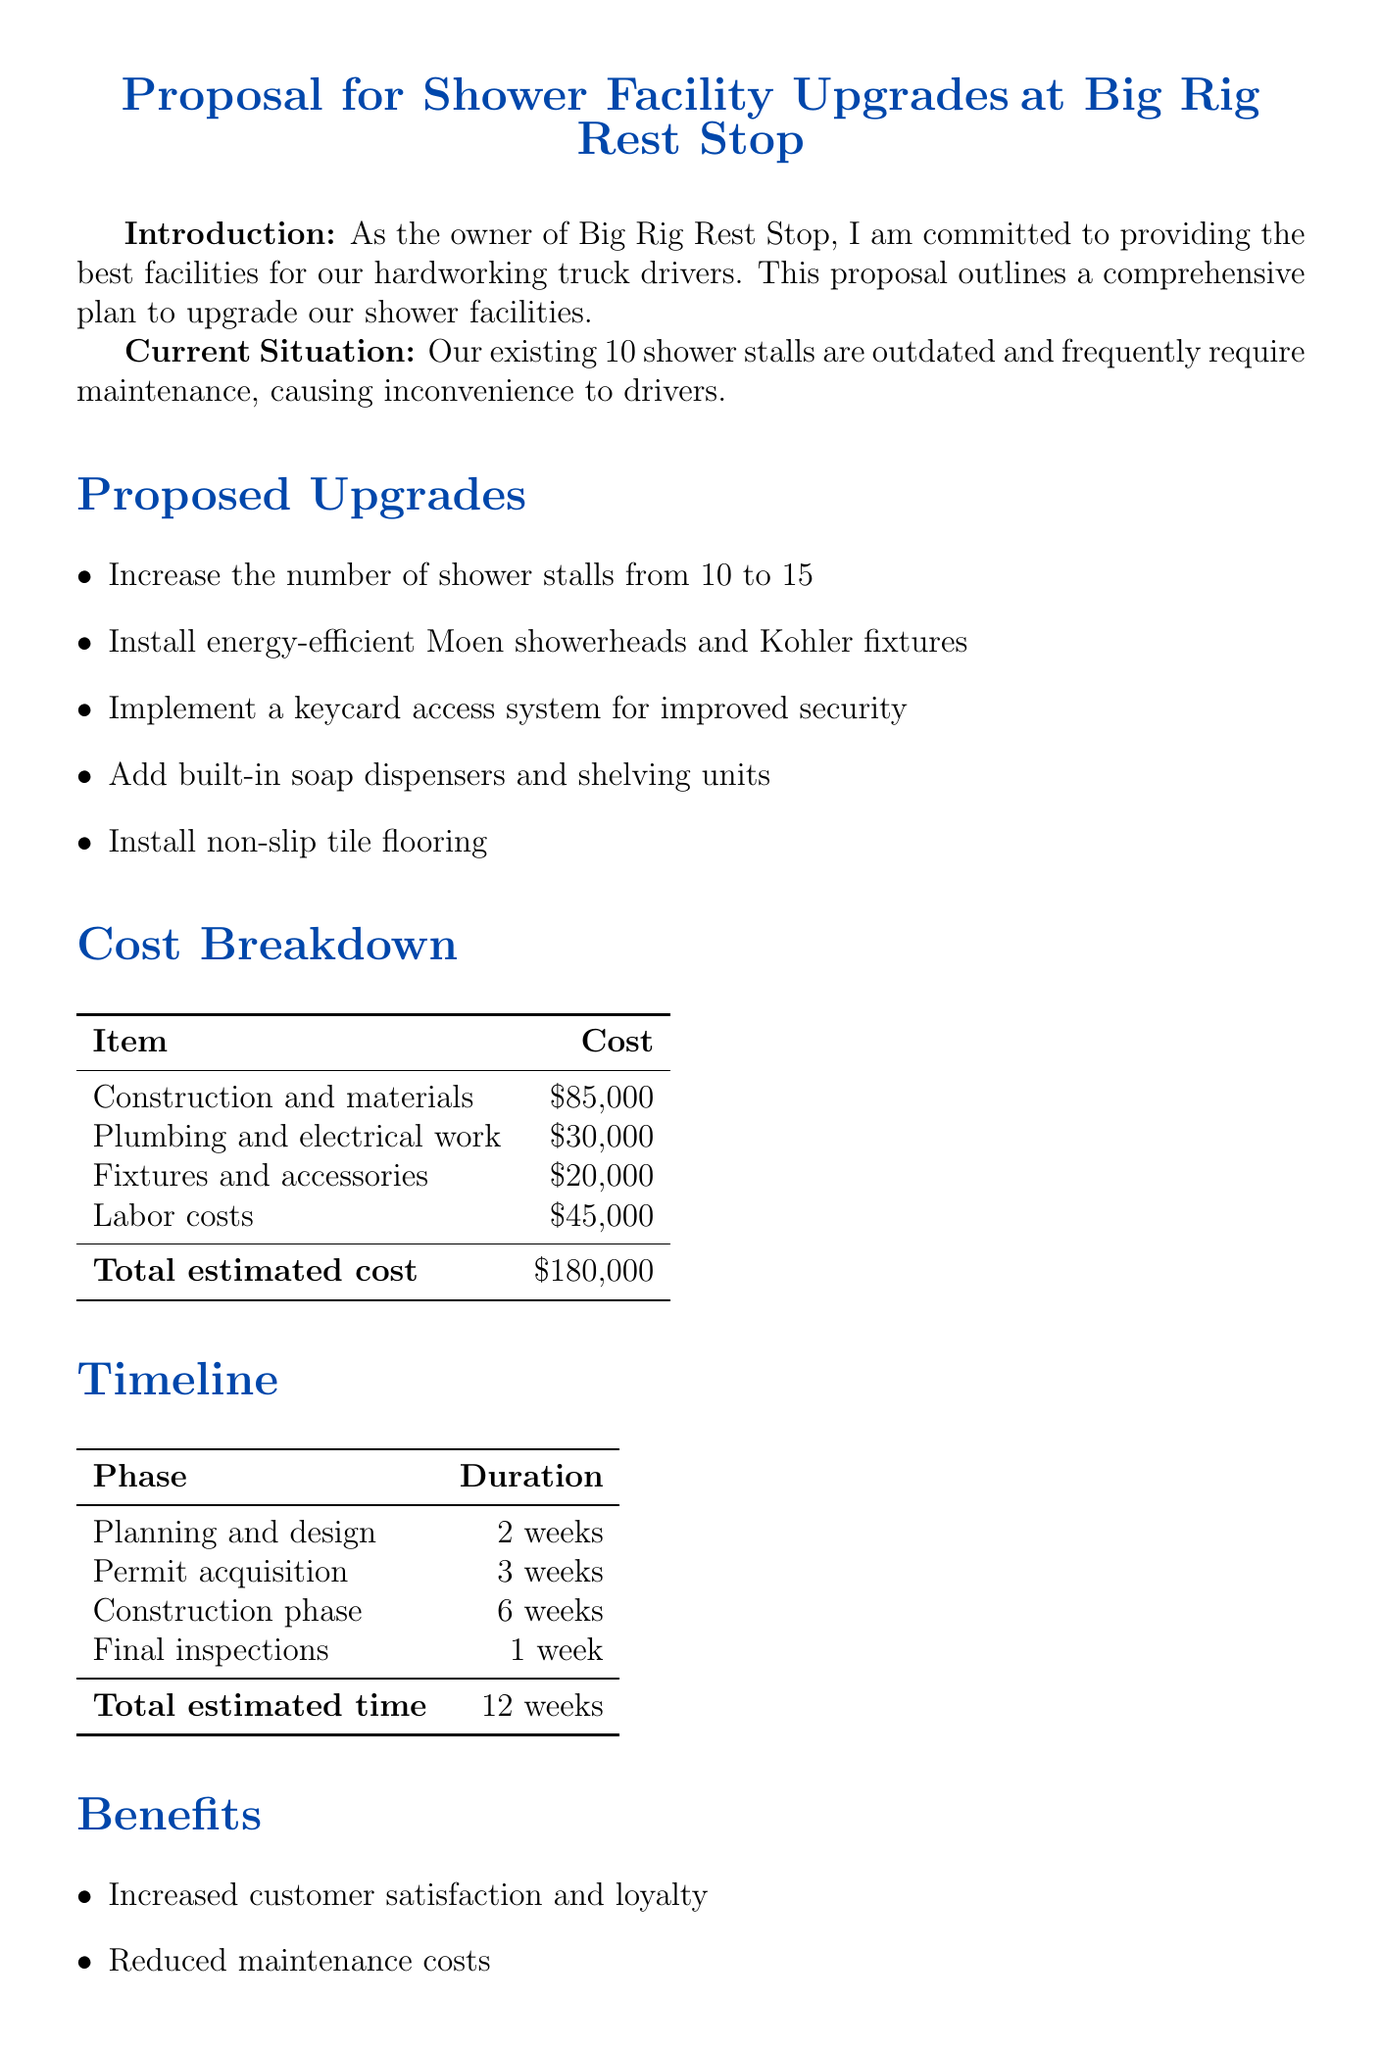What is the total estimated cost for upgrades? The total estimated cost is found in the cost breakdown section of the document.
Answer: $180,000 How many shower stalls will there be after the upgrade? The number of shower stalls after the upgrade can be found in the proposed upgrades section.
Answer: 15 What is the duration of the construction phase? The construction phase duration is listed in the timeline section of the proposal.
Answer: 6 weeks What type of showerheads will be installed? The type of showerheads is mentioned in the proposed upgrades section.
Answer: Moen showerheads What is a benefit of the proposed upgrades? Benefits are listed in the benefits section, highlighting advantages of the upgrades.
Answer: Increased customer satisfaction How long will the permit acquisition take? The duration for permit acquisition can be found in the timeline section.
Answer: 3 weeks What flooring type is planned to be installed? The type of flooring is specified in the proposed upgrades section.
Answer: Non-slip tile flooring What is the estimated duration of the entire project? The total estimated time is provided in the timeline section of the document.
Answer: 12 weeks What is the cost for plumbing and electrical work? The cost for plumbing and electrical work is detailed in the cost breakdown table.
Answer: $30,000 